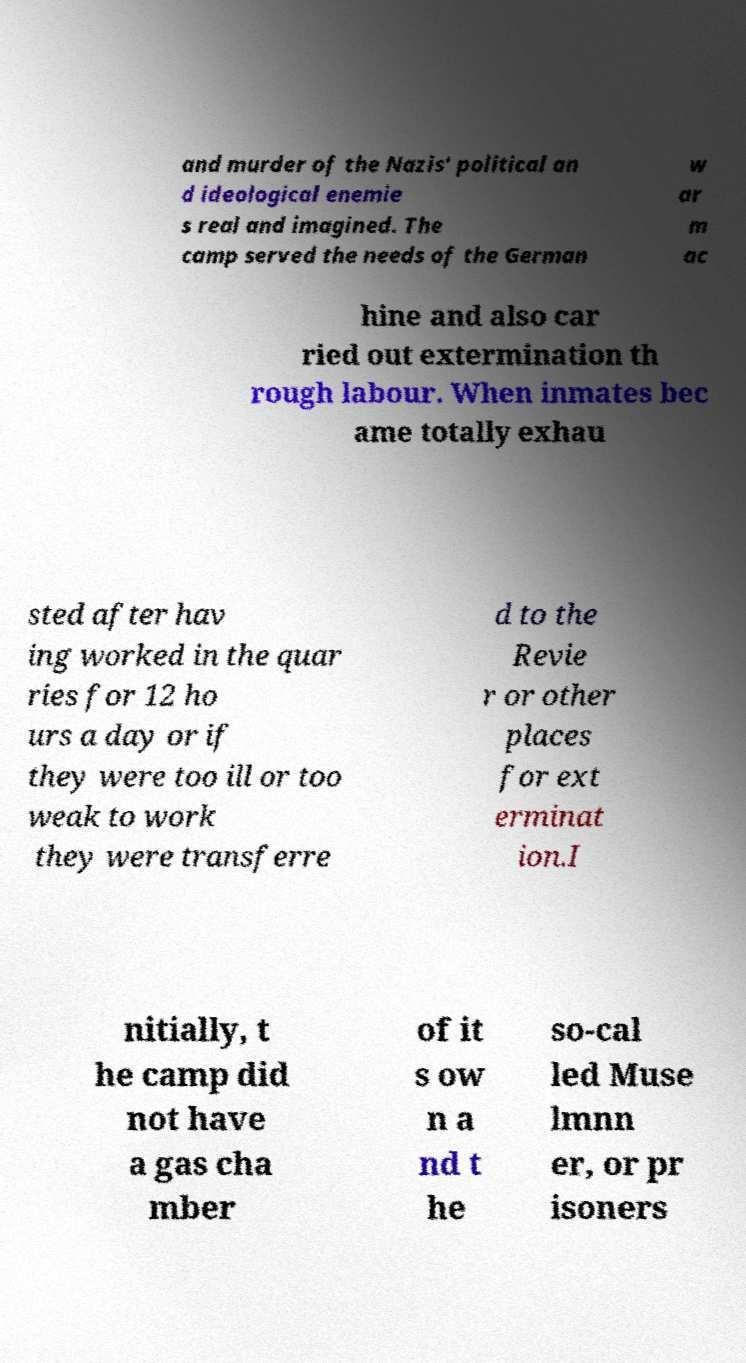Could you assist in decoding the text presented in this image and type it out clearly? and murder of the Nazis' political an d ideological enemie s real and imagined. The camp served the needs of the German w ar m ac hine and also car ried out extermination th rough labour. When inmates bec ame totally exhau sted after hav ing worked in the quar ries for 12 ho urs a day or if they were too ill or too weak to work they were transferre d to the Revie r or other places for ext erminat ion.I nitially, t he camp did not have a gas cha mber of it s ow n a nd t he so-cal led Muse lmnn er, or pr isoners 